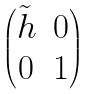<formula> <loc_0><loc_0><loc_500><loc_500>\begin{pmatrix} \tilde { h } & 0 \\ 0 & 1 \end{pmatrix}</formula> 